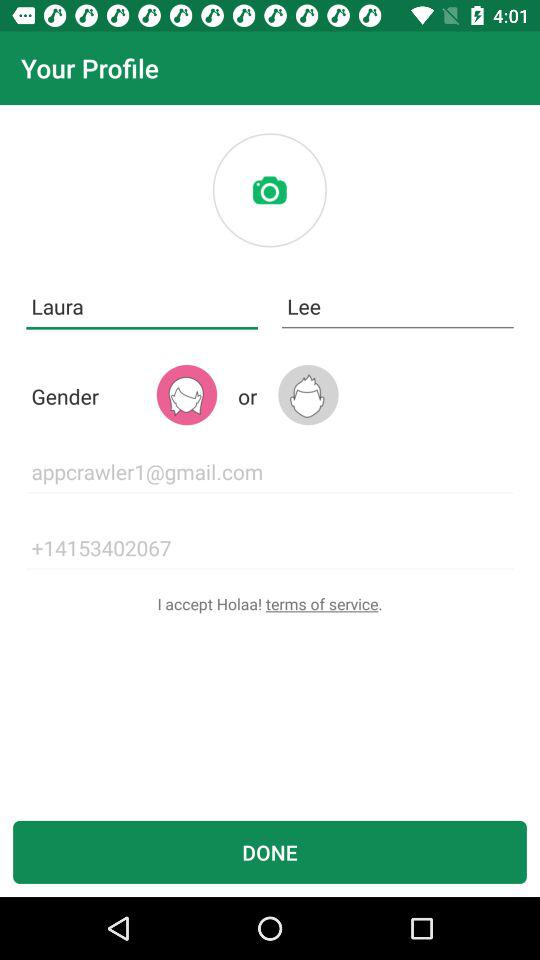How many inputs have an email address?
Answer the question using a single word or phrase. 1 